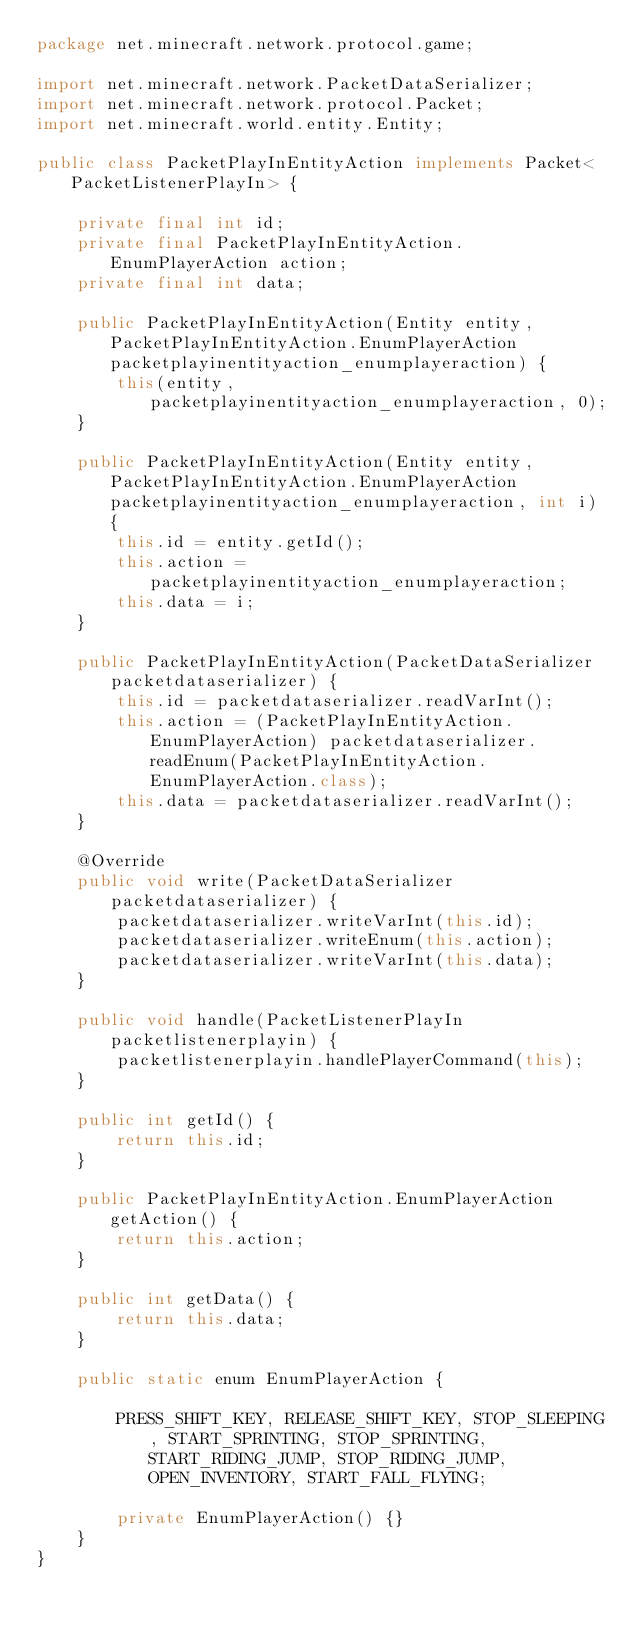<code> <loc_0><loc_0><loc_500><loc_500><_Java_>package net.minecraft.network.protocol.game;

import net.minecraft.network.PacketDataSerializer;
import net.minecraft.network.protocol.Packet;
import net.minecraft.world.entity.Entity;

public class PacketPlayInEntityAction implements Packet<PacketListenerPlayIn> {

    private final int id;
    private final PacketPlayInEntityAction.EnumPlayerAction action;
    private final int data;

    public PacketPlayInEntityAction(Entity entity, PacketPlayInEntityAction.EnumPlayerAction packetplayinentityaction_enumplayeraction) {
        this(entity, packetplayinentityaction_enumplayeraction, 0);
    }

    public PacketPlayInEntityAction(Entity entity, PacketPlayInEntityAction.EnumPlayerAction packetplayinentityaction_enumplayeraction, int i) {
        this.id = entity.getId();
        this.action = packetplayinentityaction_enumplayeraction;
        this.data = i;
    }

    public PacketPlayInEntityAction(PacketDataSerializer packetdataserializer) {
        this.id = packetdataserializer.readVarInt();
        this.action = (PacketPlayInEntityAction.EnumPlayerAction) packetdataserializer.readEnum(PacketPlayInEntityAction.EnumPlayerAction.class);
        this.data = packetdataserializer.readVarInt();
    }

    @Override
    public void write(PacketDataSerializer packetdataserializer) {
        packetdataserializer.writeVarInt(this.id);
        packetdataserializer.writeEnum(this.action);
        packetdataserializer.writeVarInt(this.data);
    }

    public void handle(PacketListenerPlayIn packetlistenerplayin) {
        packetlistenerplayin.handlePlayerCommand(this);
    }

    public int getId() {
        return this.id;
    }

    public PacketPlayInEntityAction.EnumPlayerAction getAction() {
        return this.action;
    }

    public int getData() {
        return this.data;
    }

    public static enum EnumPlayerAction {

        PRESS_SHIFT_KEY, RELEASE_SHIFT_KEY, STOP_SLEEPING, START_SPRINTING, STOP_SPRINTING, START_RIDING_JUMP, STOP_RIDING_JUMP, OPEN_INVENTORY, START_FALL_FLYING;

        private EnumPlayerAction() {}
    }
}
</code> 